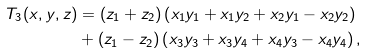<formula> <loc_0><loc_0><loc_500><loc_500>T _ { 3 } ( x , y , z ) & = ( z _ { 1 } + z _ { 2 } ) \left ( x _ { 1 } y _ { 1 } + x _ { 1 } y _ { 2 } + x _ { 2 } y _ { 1 } - x _ { 2 } y _ { 2 } \right ) \\ & + ( z _ { 1 } - z _ { 2 } ) \left ( x _ { 3 } y _ { 3 } + x _ { 3 } y _ { 4 } + x _ { 4 } y _ { 3 } - x _ { 4 } y _ { 4 } \right ) ,</formula> 